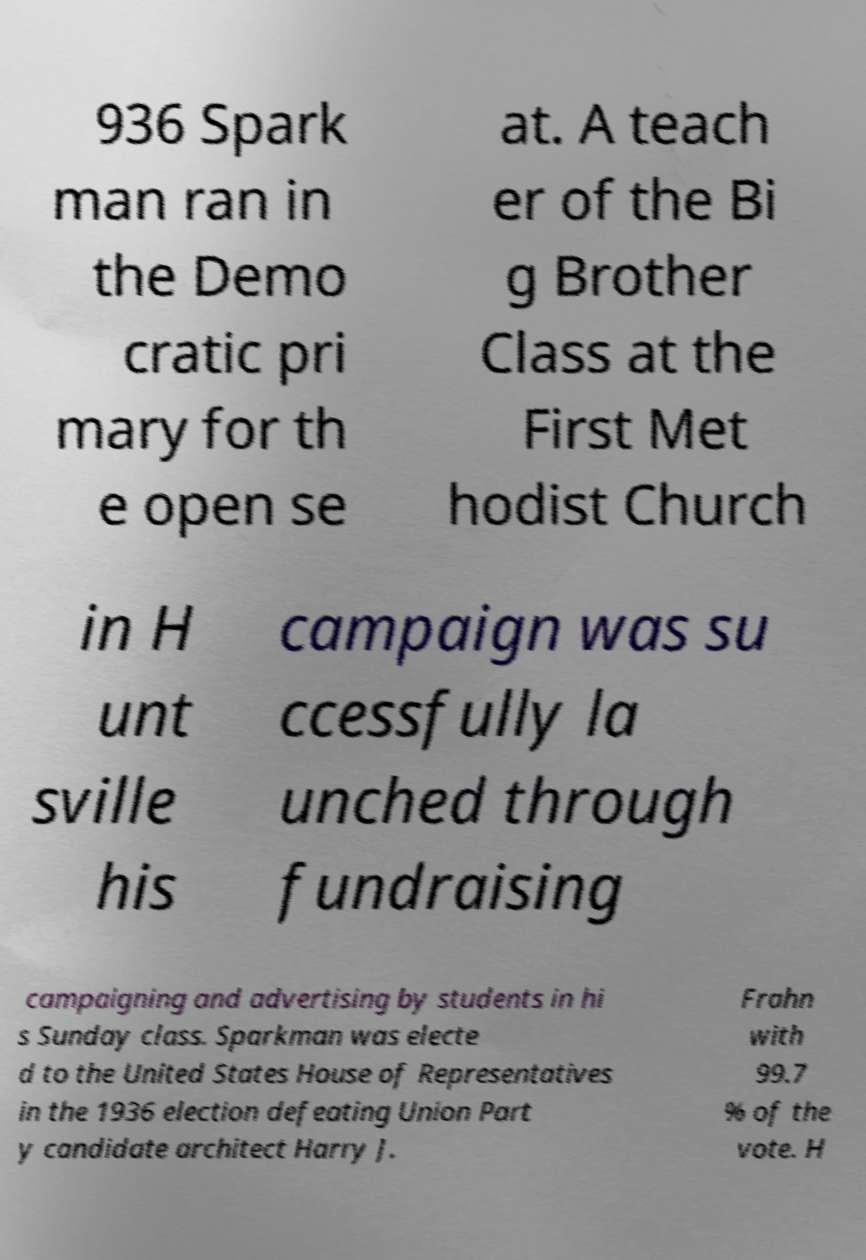There's text embedded in this image that I need extracted. Can you transcribe it verbatim? 936 Spark man ran in the Demo cratic pri mary for th e open se at. A teach er of the Bi g Brother Class at the First Met hodist Church in H unt sville his campaign was su ccessfully la unched through fundraising campaigning and advertising by students in hi s Sunday class. Sparkman was electe d to the United States House of Representatives in the 1936 election defeating Union Part y candidate architect Harry J. Frahn with 99.7 % of the vote. H 